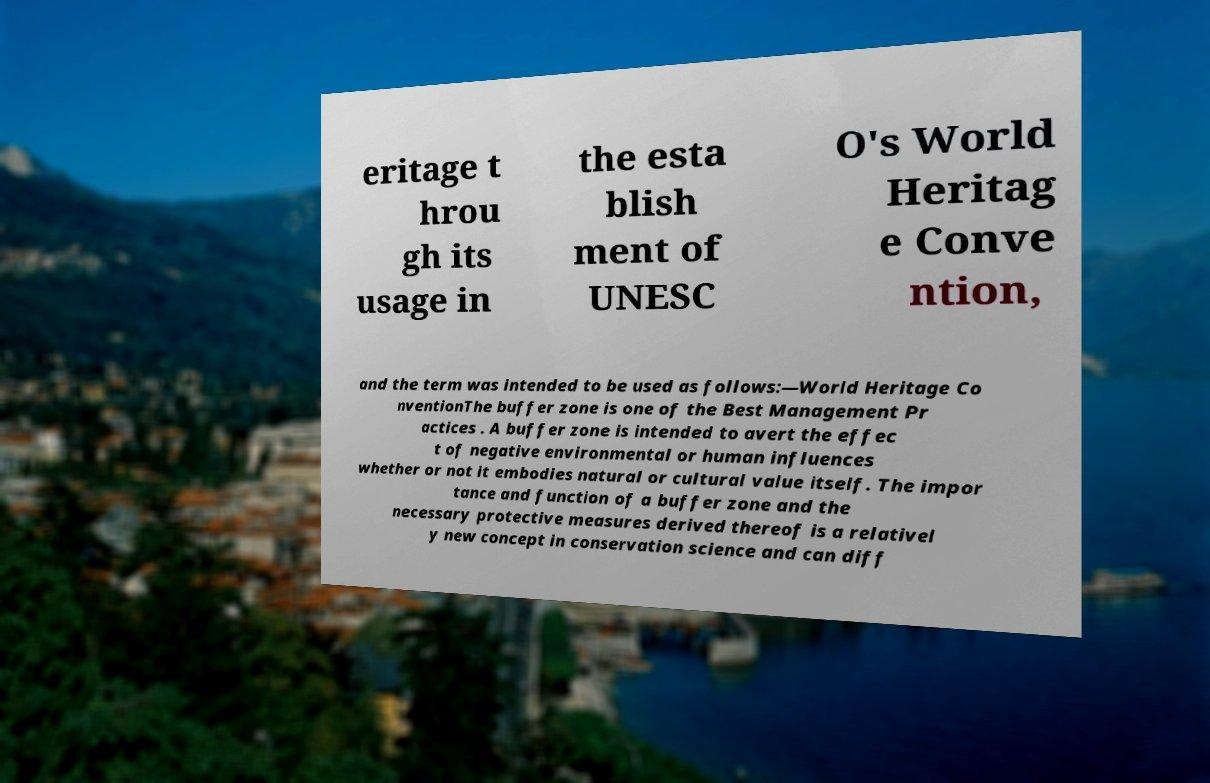Could you assist in decoding the text presented in this image and type it out clearly? eritage t hrou gh its usage in the esta blish ment of UNESC O's World Heritag e Conve ntion, and the term was intended to be used as follows:—World Heritage Co nventionThe buffer zone is one of the Best Management Pr actices . A buffer zone is intended to avert the effec t of negative environmental or human influences whether or not it embodies natural or cultural value itself. The impor tance and function of a buffer zone and the necessary protective measures derived thereof is a relativel y new concept in conservation science and can diff 